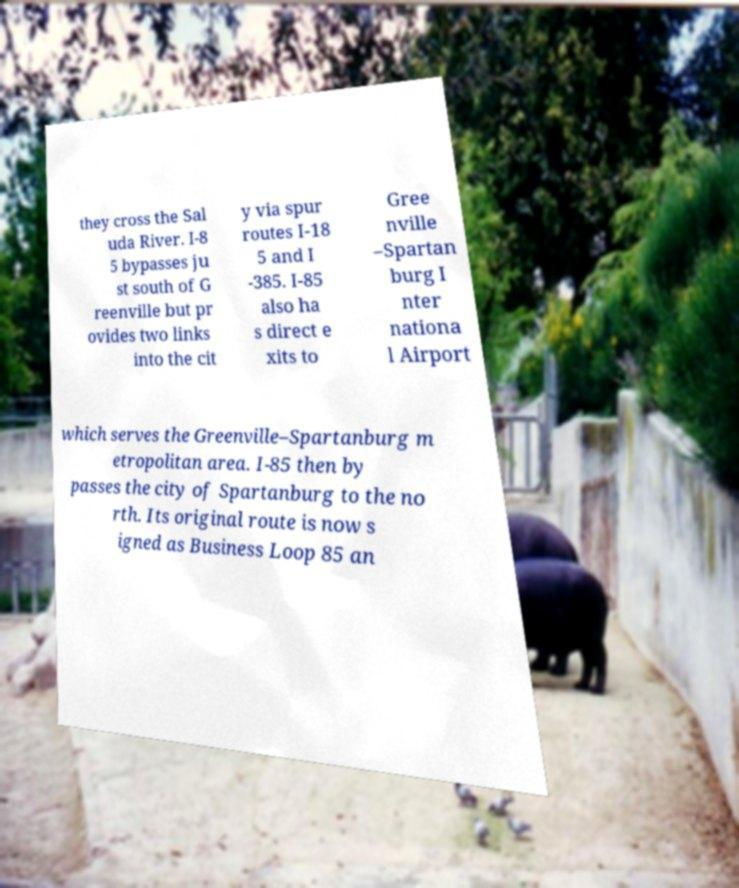Please read and relay the text visible in this image. What does it say? they cross the Sal uda River. I-8 5 bypasses ju st south of G reenville but pr ovides two links into the cit y via spur routes I-18 5 and I -385. I-85 also ha s direct e xits to Gree nville –Spartan burg I nter nationa l Airport which serves the Greenville–Spartanburg m etropolitan area. I-85 then by passes the city of Spartanburg to the no rth. Its original route is now s igned as Business Loop 85 an 